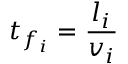Convert formula to latex. <formula><loc_0><loc_0><loc_500><loc_500>t _ { f _ { i } } = \frac { l _ { i } } { v _ { i } }</formula> 